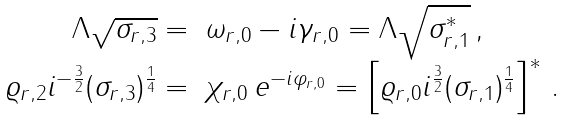<formula> <loc_0><loc_0><loc_500><loc_500>\begin{array} { r l } { { \Lambda \sqrt { \sigma _ { r , 3 } } = } } & { { \omega _ { r , 0 } - i \gamma _ { r , 0 } = \Lambda \sqrt { \sigma _ { r , 1 } ^ { * } } \, , } } \\ { { \varrho _ { r , 2 } i ^ { - \frac { 3 } { 2 } } ( \sigma _ { r , 3 } ) ^ { \frac { 1 } { 4 } } = } } & { { \chi _ { r , 0 } \, e ^ { - i \varphi _ { r , 0 } } = \left [ \varrho _ { r , 0 } i ^ { \frac { 3 } { 2 } } ( \sigma _ { r , 1 } ) ^ { \frac { 1 } { 4 } } \right ] ^ { * } \, . } } \end{array}</formula> 